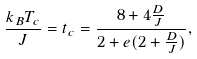<formula> <loc_0><loc_0><loc_500><loc_500>\frac { k _ { B } T _ { c } } { J } = t _ { c } = \frac { 8 + 4 \frac { D } { J } } { 2 + e ( 2 + \frac { D } { J } ) } ,</formula> 